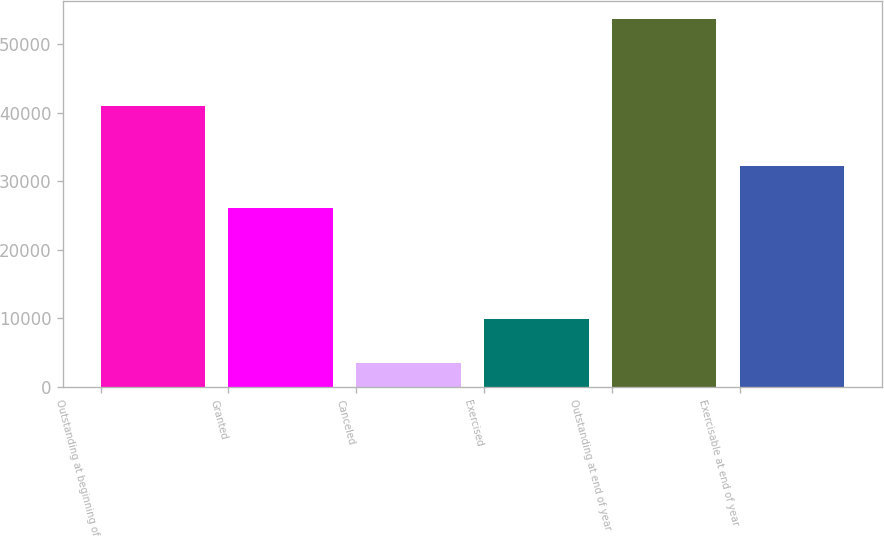Convert chart to OTSL. <chart><loc_0><loc_0><loc_500><loc_500><bar_chart><fcel>Outstanding at beginning of<fcel>Granted<fcel>Canceled<fcel>Exercised<fcel>Outstanding at end of year<fcel>Exercisable at end of year<nl><fcel>40969<fcel>26121<fcel>3425<fcel>9981<fcel>53684<fcel>32250<nl></chart> 